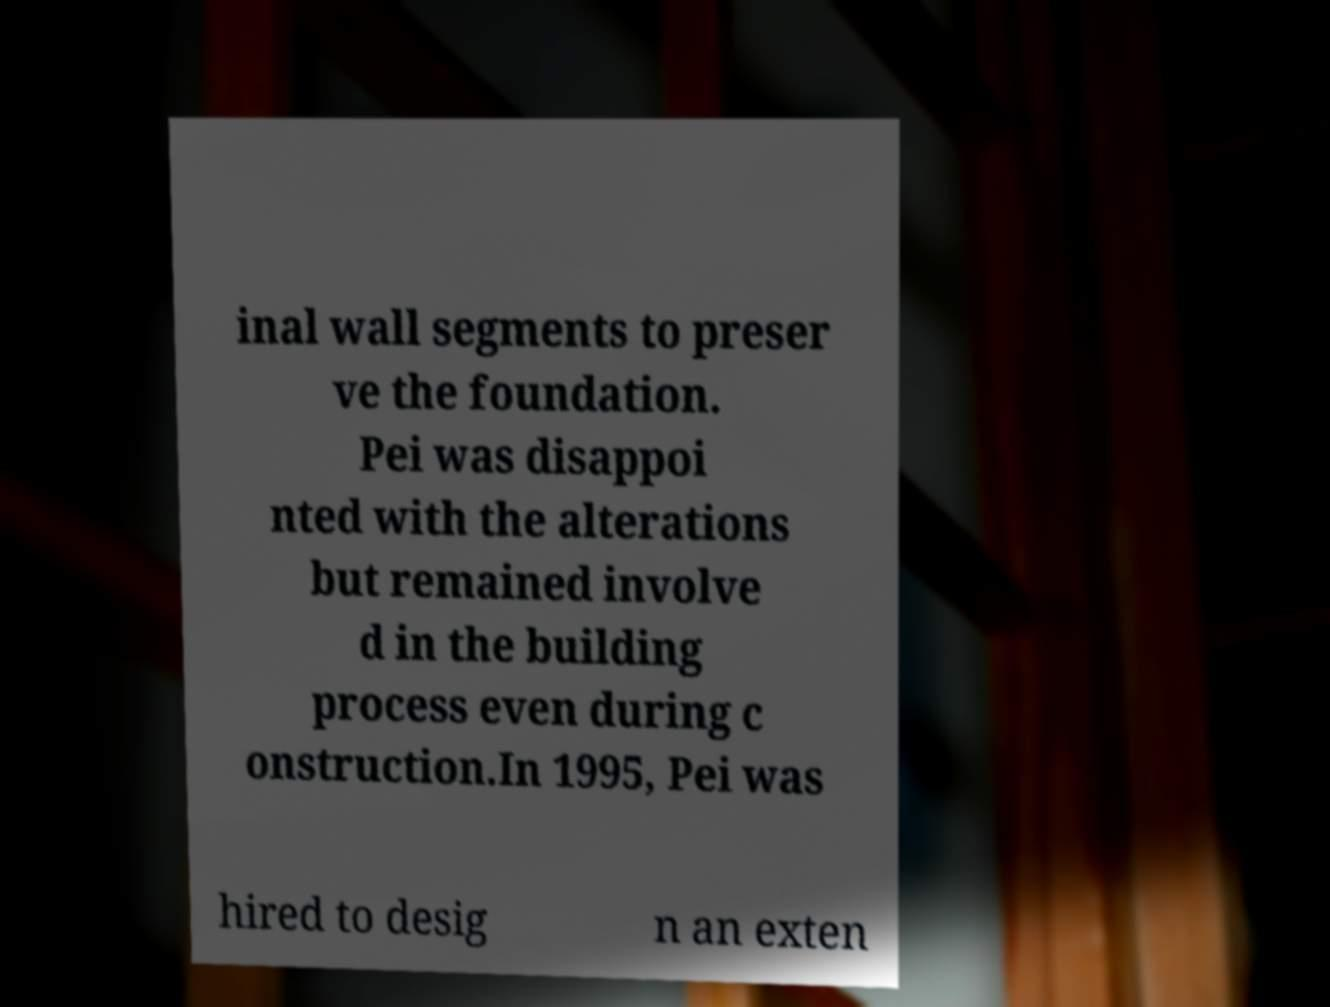Please read and relay the text visible in this image. What does it say? inal wall segments to preser ve the foundation. Pei was disappoi nted with the alterations but remained involve d in the building process even during c onstruction.In 1995, Pei was hired to desig n an exten 